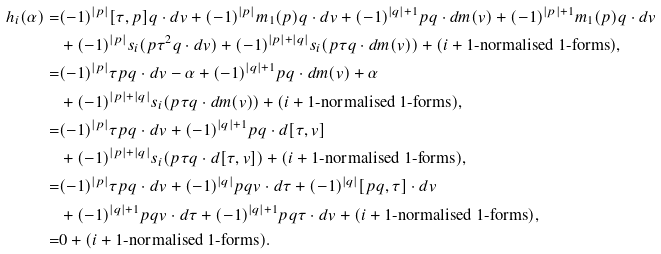Convert formula to latex. <formula><loc_0><loc_0><loc_500><loc_500>h _ { i } ( \alpha ) = & ( - 1 ) ^ { | p | } [ \tau , p ] q \cdot d v + ( - 1 ) ^ { | p | } m _ { 1 } ( p ) q \cdot d v + ( - 1 ) ^ { | q | + 1 } p q \cdot d m ( v ) + ( - 1 ) ^ { | p | + 1 } m _ { 1 } ( p ) q \cdot d v \\ & + ( - 1 ) ^ { | p | } s _ { i } ( p \tau ^ { 2 } q \cdot d v ) + ( - 1 ) ^ { | p | + | q | } s _ { i } ( p \tau q \cdot d m ( v ) ) + ( \text {$i+1$-normalised 1-forms} ) , \\ = & ( - 1 ) ^ { | p | } \tau p q \cdot d v - \alpha + ( - 1 ) ^ { | q | + 1 } p q \cdot d m ( v ) + \alpha \\ & + ( - 1 ) ^ { | p | + | q | } s _ { i } ( p \tau q \cdot d m ( v ) ) + ( \text {$i+1$-normalised 1-forms} ) , \\ = & ( - 1 ) ^ { | p | } \tau p q \cdot d v + ( - 1 ) ^ { | q | + 1 } p q \cdot d [ \tau , v ] \\ & + ( - 1 ) ^ { | p | + | q | } s _ { i } ( p \tau q \cdot d [ \tau , v ] ) + ( \text {$i+1$-normalised 1-forms} ) , \\ = & ( - 1 ) ^ { | p | } \tau p q \cdot d v + ( - 1 ) ^ { | q | } p q v \cdot d \tau + ( - 1 ) ^ { | q | } [ p q , \tau ] \cdot d v \\ & + ( - 1 ) ^ { | q | + 1 } p q v \cdot d \tau + ( - 1 ) ^ { | q | + 1 } p q \tau \cdot d v + ( \text {$i+1$-normalised 1-forms} ) , \\ = & 0 + ( \text {$i+1$-normalised 1-forms} ) . \\</formula> 